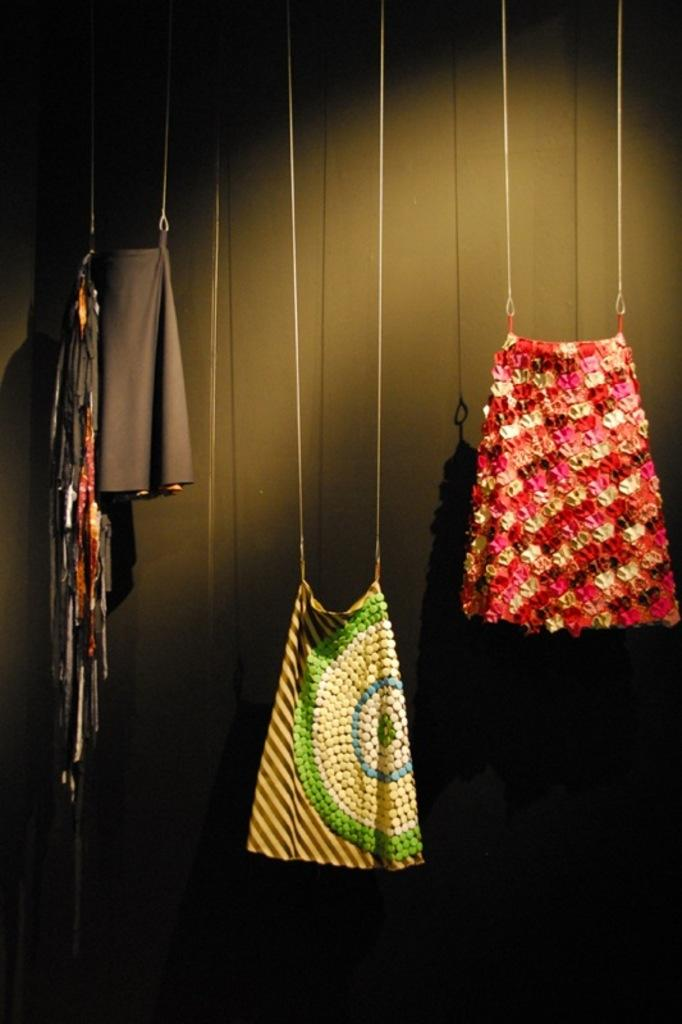How many clothes can be seen hanging in the image? There are three different clothes hanging in the image. How are the clothes suspended in the image? The clothes are hanging with the help of a rope. What can be seen in the background of the image? There is a black color wall in the background of the image. Can you describe the thought process of the ocean in the image? There is no ocean present in the image, so it is not possible to describe its thought process. 